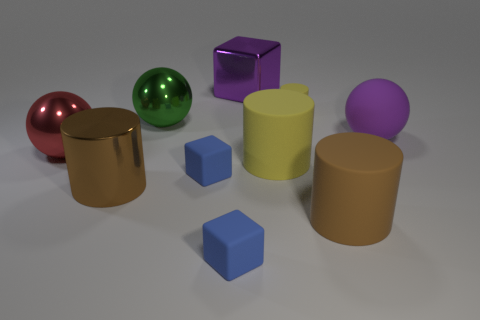Subtract 1 cubes. How many cubes are left? 2 Subtract all small matte cubes. How many cubes are left? 1 Subtract all cyan cylinders. Subtract all green spheres. How many cylinders are left? 4 Subtract all blocks. How many objects are left? 7 Add 10 large brown matte blocks. How many large brown matte blocks exist? 10 Subtract 0 green cylinders. How many objects are left? 10 Subtract all large blue metallic spheres. Subtract all large blocks. How many objects are left? 9 Add 4 metal things. How many metal things are left? 8 